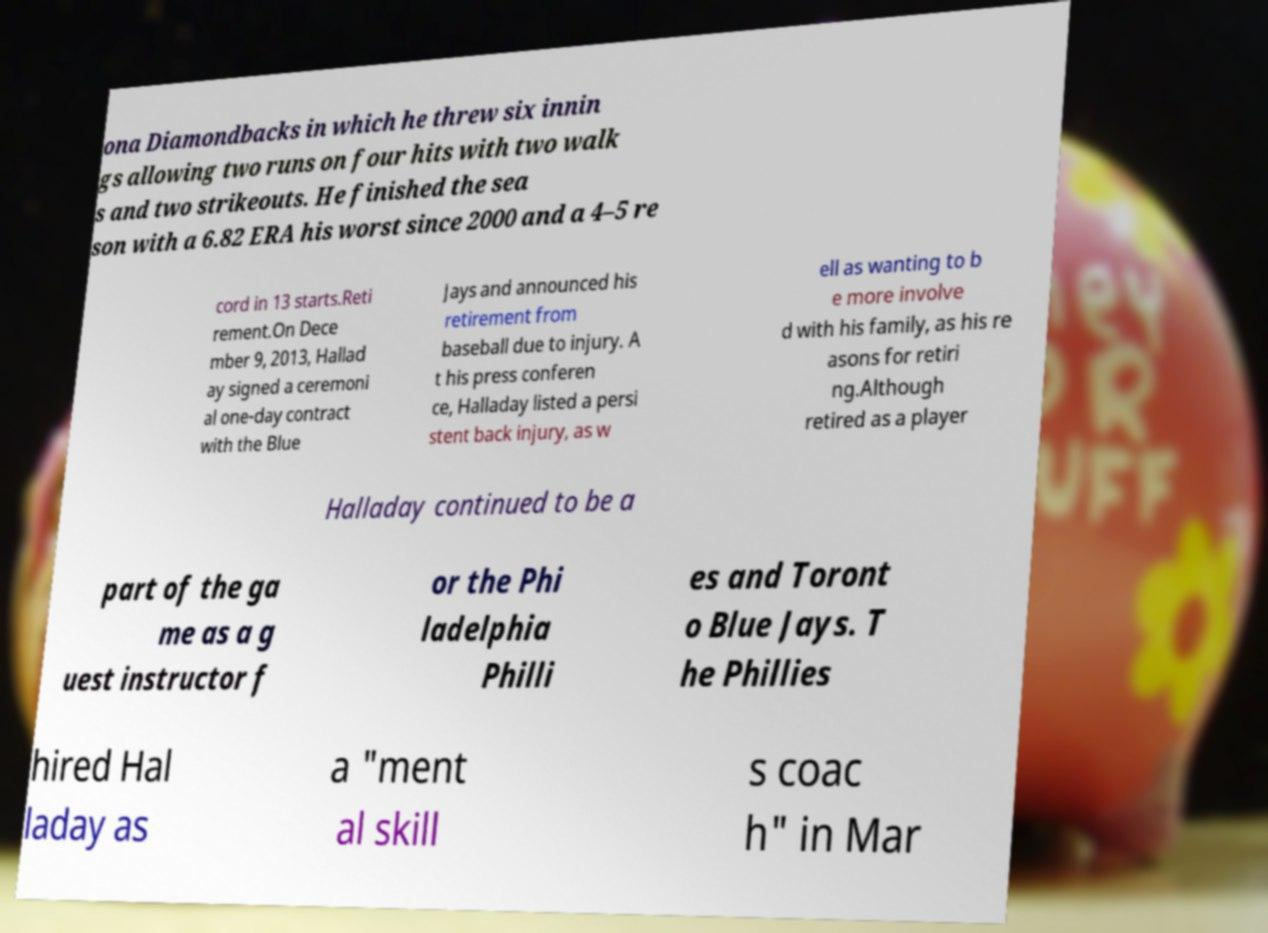Please identify and transcribe the text found in this image. ona Diamondbacks in which he threw six innin gs allowing two runs on four hits with two walk s and two strikeouts. He finished the sea son with a 6.82 ERA his worst since 2000 and a 4–5 re cord in 13 starts.Reti rement.On Dece mber 9, 2013, Hallad ay signed a ceremoni al one-day contract with the Blue Jays and announced his retirement from baseball due to injury. A t his press conferen ce, Halladay listed a persi stent back injury, as w ell as wanting to b e more involve d with his family, as his re asons for retiri ng.Although retired as a player Halladay continued to be a part of the ga me as a g uest instructor f or the Phi ladelphia Philli es and Toront o Blue Jays. T he Phillies hired Hal laday as a "ment al skill s coac h" in Mar 